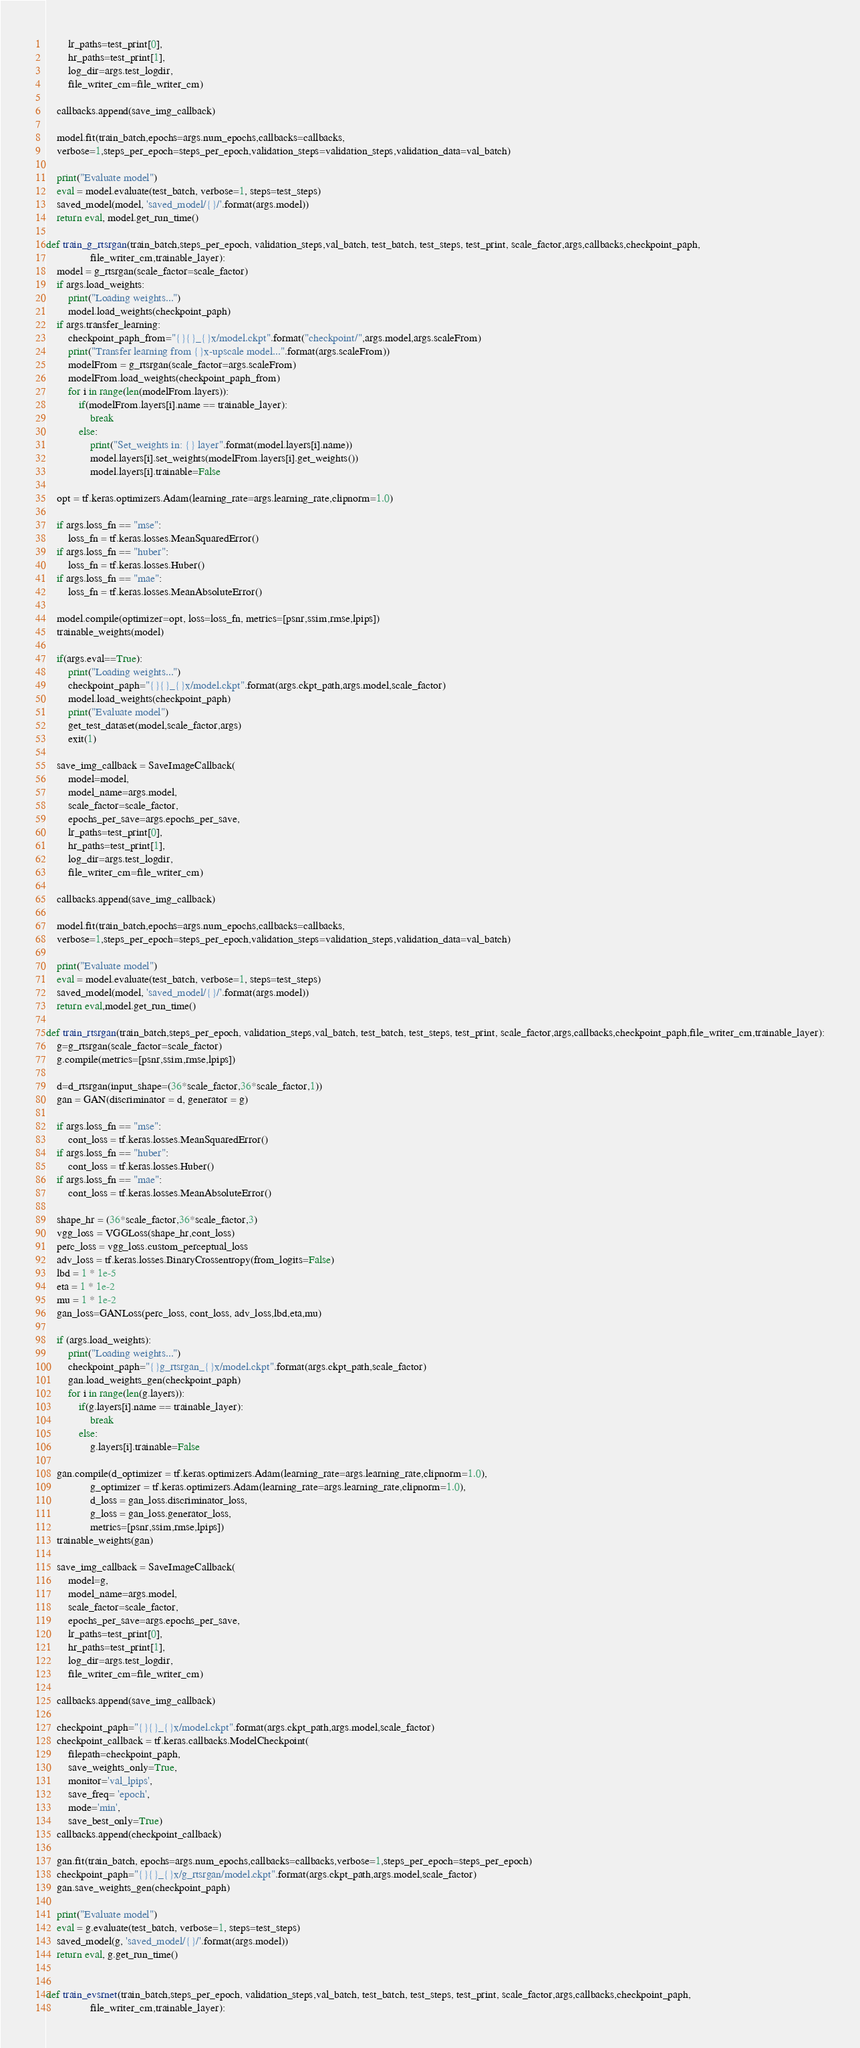<code> <loc_0><loc_0><loc_500><loc_500><_Python_>        lr_paths=test_print[0],
        hr_paths=test_print[1],
        log_dir=args.test_logdir,
        file_writer_cm=file_writer_cm)

    callbacks.append(save_img_callback)

    model.fit(train_batch,epochs=args.num_epochs,callbacks=callbacks,
    verbose=1,steps_per_epoch=steps_per_epoch,validation_steps=validation_steps,validation_data=val_batch)

    print("Evaluate model")
    eval = model.evaluate(test_batch, verbose=1, steps=test_steps)
    saved_model(model, 'saved_model/{}/'.format(args.model))
    return eval, model.get_run_time()

def train_g_rtsrgan(train_batch,steps_per_epoch, validation_steps,val_batch, test_batch, test_steps, test_print, scale_factor,args,callbacks,checkpoint_paph,
                file_writer_cm,trainable_layer):
    model = g_rtsrgan(scale_factor=scale_factor)
    if args.load_weights:
        print("Loading weights...")
        model.load_weights(checkpoint_paph)
    if args.transfer_learning:
        checkpoint_paph_from="{}{}_{}x/model.ckpt".format("checkpoint/",args.model,args.scaleFrom)
        print("Transfer learning from {}x-upscale model...".format(args.scaleFrom))
        modelFrom = g_rtsrgan(scale_factor=args.scaleFrom)
        modelFrom.load_weights(checkpoint_paph_from)
        for i in range(len(modelFrom.layers)):
            if(modelFrom.layers[i].name == trainable_layer):
                break
            else:
                print("Set_weights in: {} layer".format(model.layers[i].name))
                model.layers[i].set_weights(modelFrom.layers[i].get_weights())
                model.layers[i].trainable=False
    
    opt = tf.keras.optimizers.Adam(learning_rate=args.learning_rate,clipnorm=1.0)

    if args.loss_fn == "mse":
        loss_fn = tf.keras.losses.MeanSquaredError()        
    if args.loss_fn == "huber":
        loss_fn = tf.keras.losses.Huber()
    if args.loss_fn == "mae":
        loss_fn = tf.keras.losses.MeanAbsoluteError()

    model.compile(optimizer=opt, loss=loss_fn, metrics=[psnr,ssim,rmse,lpips])
    trainable_weights(model)

    if(args.eval==True):
        print("Loading weights...")
        checkpoint_paph="{}{}_{}x/model.ckpt".format(args.ckpt_path,args.model,scale_factor) 
        model.load_weights(checkpoint_paph)
        print("Evaluate model")
        get_test_dataset(model,scale_factor,args)
        exit(1)

    save_img_callback = SaveImageCallback(
        model=model,
        model_name=args.model,
        scale_factor=scale_factor,
        epochs_per_save=args.epochs_per_save,
        lr_paths=test_print[0],
        hr_paths=test_print[1],
        log_dir=args.test_logdir,
        file_writer_cm=file_writer_cm)

    callbacks.append(save_img_callback)

    model.fit(train_batch,epochs=args.num_epochs,callbacks=callbacks,
    verbose=1,steps_per_epoch=steps_per_epoch,validation_steps=validation_steps,validation_data=val_batch)

    print("Evaluate model")
    eval = model.evaluate(test_batch, verbose=1, steps=test_steps)
    saved_model(model, 'saved_model/{}/'.format(args.model))
    return eval,model.get_run_time()

def train_rtsrgan(train_batch,steps_per_epoch, validation_steps,val_batch, test_batch, test_steps, test_print, scale_factor,args,callbacks,checkpoint_paph,file_writer_cm,trainable_layer):
    g=g_rtsrgan(scale_factor=scale_factor)
    g.compile(metrics=[psnr,ssim,rmse,lpips])
    
    d=d_rtsrgan(input_shape=(36*scale_factor,36*scale_factor,1))
    gan = GAN(discriminator = d, generator = g)

    if args.loss_fn == "mse":
        cont_loss = tf.keras.losses.MeanSquaredError()        
    if args.loss_fn == "huber":
        cont_loss = tf.keras.losses.Huber()
    if args.loss_fn == "mae":
        cont_loss = tf.keras.losses.MeanAbsoluteError()

    shape_hr = (36*scale_factor,36*scale_factor,3)    
    vgg_loss = VGGLoss(shape_hr,cont_loss)
    perc_loss = vgg_loss.custom_perceptual_loss
    adv_loss = tf.keras.losses.BinaryCrossentropy(from_logits=False)
    lbd = 1 * 1e-5
    eta = 1 * 1e-2
    mu = 1 * 1e-2
    gan_loss=GANLoss(perc_loss, cont_loss, adv_loss,lbd,eta,mu)
        
    if (args.load_weights):
        print("Loading weights...")
        checkpoint_paph="{}g_rtsrgan_{}x/model.ckpt".format(args.ckpt_path,scale_factor) 
        gan.load_weights_gen(checkpoint_paph)
        for i in range(len(g.layers)):
            if(g.layers[i].name == trainable_layer):
                break
            else:
                g.layers[i].trainable=False
    
    gan.compile(d_optimizer = tf.keras.optimizers.Adam(learning_rate=args.learning_rate,clipnorm=1.0),
                g_optimizer = tf.keras.optimizers.Adam(learning_rate=args.learning_rate,clipnorm=1.0),
                d_loss = gan_loss.discriminator_loss,
                g_loss = gan_loss.generator_loss,
                metrics=[psnr,ssim,rmse,lpips])
    trainable_weights(gan)

    save_img_callback = SaveImageCallback(
        model=g,
        model_name=args.model,
        scale_factor=scale_factor,
        epochs_per_save=args.epochs_per_save,
        lr_paths=test_print[0],
        hr_paths=test_print[1],
        log_dir=args.test_logdir,
        file_writer_cm=file_writer_cm)

    callbacks.append(save_img_callback)

    checkpoint_paph="{}{}_{}x/model.ckpt".format(args.ckpt_path,args.model,scale_factor)
    checkpoint_callback = tf.keras.callbacks.ModelCheckpoint(
        filepath=checkpoint_paph,
        save_weights_only=True,
        monitor='val_lpips',
        save_freq= 'epoch', 
        mode='min',
        save_best_only=True)
    callbacks.append(checkpoint_callback)

    gan.fit(train_batch, epochs=args.num_epochs,callbacks=callbacks,verbose=1,steps_per_epoch=steps_per_epoch)
    checkpoint_paph="{}{}_{}x/g_rtsrgan/model.ckpt".format(args.ckpt_path,args.model,scale_factor) 
    gan.save_weights_gen(checkpoint_paph)

    print("Evaluate model")
    eval = g.evaluate(test_batch, verbose=1, steps=test_steps)
    saved_model(g, 'saved_model/{}/'.format(args.model))
    return eval, g.get_run_time()


def train_evsrnet(train_batch,steps_per_epoch, validation_steps,val_batch, test_batch, test_steps, test_print, scale_factor,args,callbacks,checkpoint_paph,
                file_writer_cm,trainable_layer):</code> 